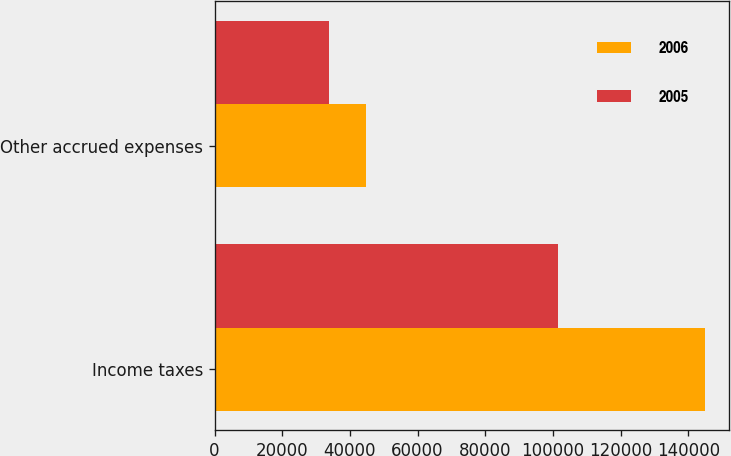Convert chart. <chart><loc_0><loc_0><loc_500><loc_500><stacked_bar_chart><ecel><fcel>Income taxes<fcel>Other accrued expenses<nl><fcel>2006<fcel>144838<fcel>44849<nl><fcel>2005<fcel>101406<fcel>33747<nl></chart> 